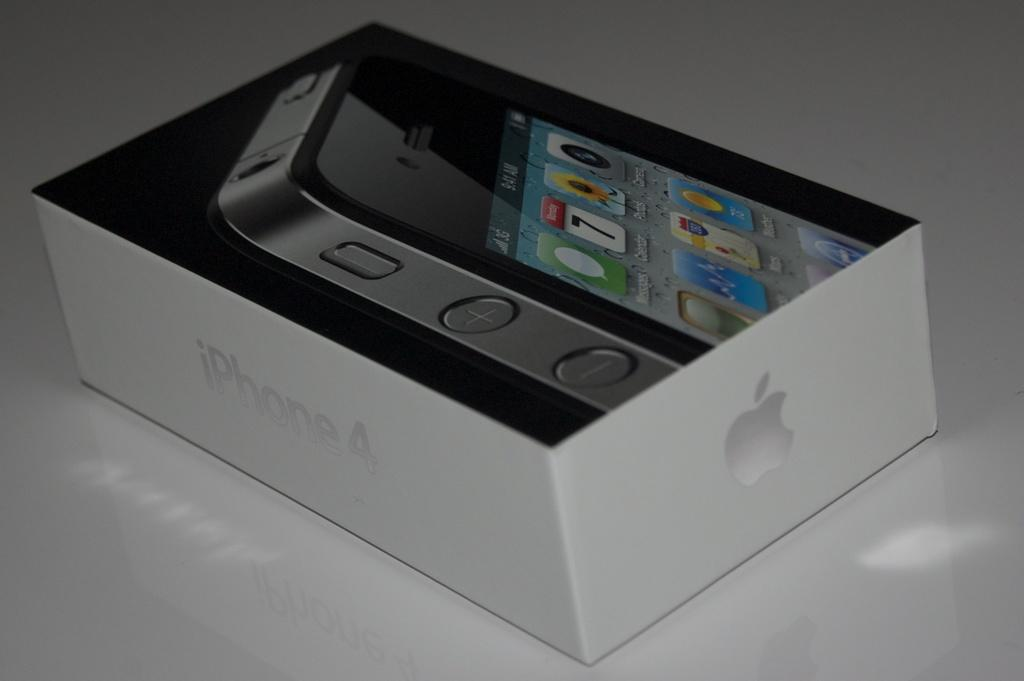<image>
Share a concise interpretation of the image provided. a white box with the word iPhone on the side 